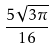Convert formula to latex. <formula><loc_0><loc_0><loc_500><loc_500>\frac { 5 \sqrt { 3 \pi } } { 1 6 }</formula> 